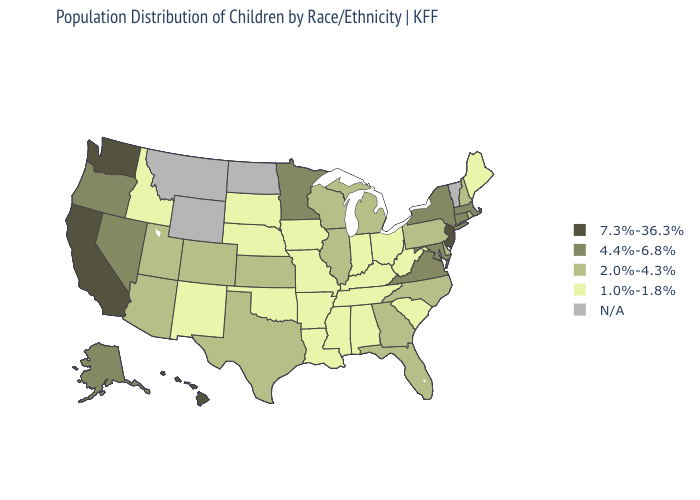What is the highest value in the USA?
Give a very brief answer. 7.3%-36.3%. What is the value of North Dakota?
Write a very short answer. N/A. What is the lowest value in states that border Nevada?
Quick response, please. 1.0%-1.8%. Name the states that have a value in the range 7.3%-36.3%?
Answer briefly. California, Hawaii, New Jersey, Washington. What is the lowest value in the USA?
Short answer required. 1.0%-1.8%. What is the value of Michigan?
Keep it brief. 2.0%-4.3%. Does the map have missing data?
Keep it brief. Yes. Is the legend a continuous bar?
Concise answer only. No. Name the states that have a value in the range 7.3%-36.3%?
Concise answer only. California, Hawaii, New Jersey, Washington. What is the lowest value in states that border Louisiana?
Be succinct. 1.0%-1.8%. What is the value of Minnesota?
Be succinct. 4.4%-6.8%. What is the value of Hawaii?
Concise answer only. 7.3%-36.3%. Name the states that have a value in the range 1.0%-1.8%?
Concise answer only. Alabama, Arkansas, Idaho, Indiana, Iowa, Kentucky, Louisiana, Maine, Mississippi, Missouri, Nebraska, New Mexico, Ohio, Oklahoma, South Carolina, South Dakota, Tennessee, West Virginia. Among the states that border Massachusetts , does Rhode Island have the highest value?
Quick response, please. No. Does Missouri have the highest value in the MidWest?
Concise answer only. No. 